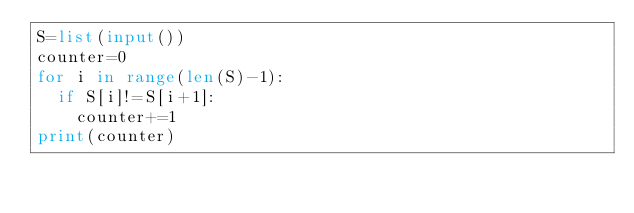Convert code to text. <code><loc_0><loc_0><loc_500><loc_500><_Python_>S=list(input())
counter=0
for i in range(len(S)-1):
  if S[i]!=S[i+1]:
    counter+=1
print(counter)</code> 